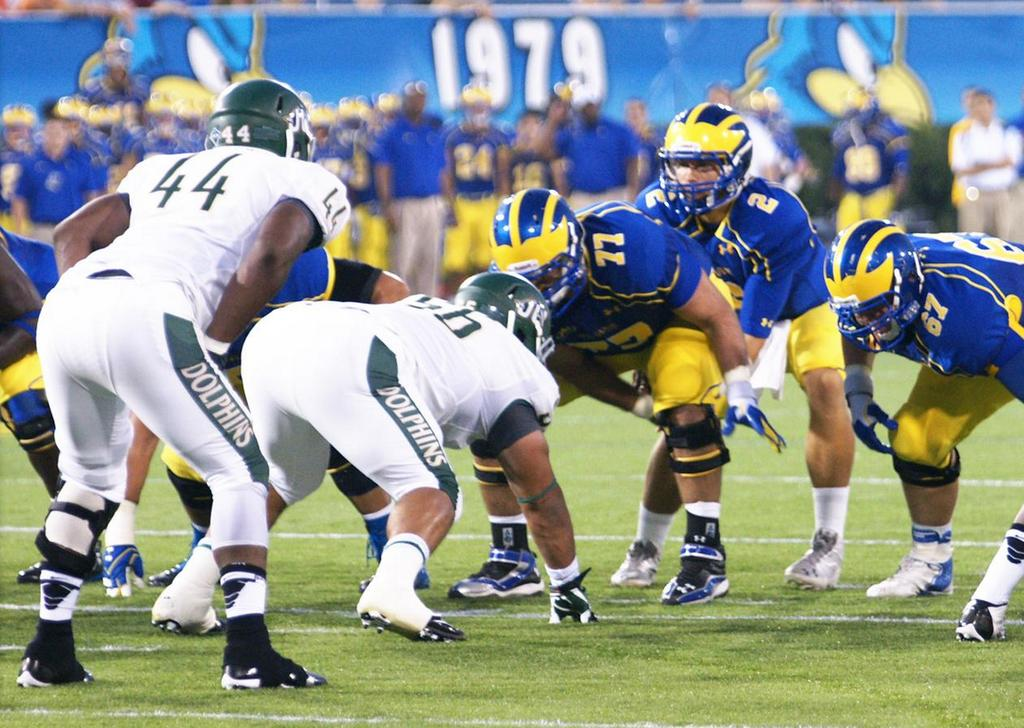What sport are the players in the foreground of the picture playing? The players in the foreground are playing rugby. What is the surface on which the rugby game is being played? The ground is covered with grass. Can you describe the background of the image? The background of the image is blurred, and there are people and a banner visible. What type of badge can be seen on the scarecrow in the background of the image? There is no scarecrow present in the image, so there is no badge to be seen. 